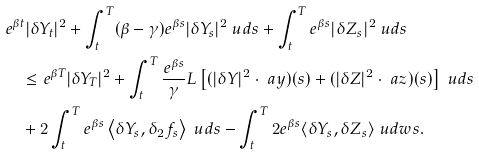<formula> <loc_0><loc_0><loc_500><loc_500>& e ^ { \beta t } | \delta Y _ { t } | ^ { 2 } + \int _ { t } ^ { T } ( \beta - \gamma ) e ^ { \beta s } | \delta Y _ { s } | ^ { 2 } \ u d s + \int _ { t } ^ { T } e ^ { \beta s } | \delta Z _ { s } | ^ { 2 } \ u d s \\ & \quad \leq e ^ { \beta T } | \delta Y _ { T } | ^ { 2 } + \int _ { t } ^ { T } \frac { e ^ { \beta s } } { \gamma } L \left [ ( | \delta Y | ^ { 2 } \cdot \ a y ) ( s ) + ( | \delta Z | ^ { 2 } \cdot \ a z ) ( s ) \right ] \ u d s \\ & \quad + 2 \int _ { t } ^ { T } e ^ { \beta s } \left \langle \delta Y _ { s } , \delta _ { 2 } f _ { s } \right \rangle \ u d s - \int _ { t } ^ { T } 2 e ^ { \beta s } \langle \delta Y _ { s } , \delta Z _ { s } \rangle \ u d w s .</formula> 